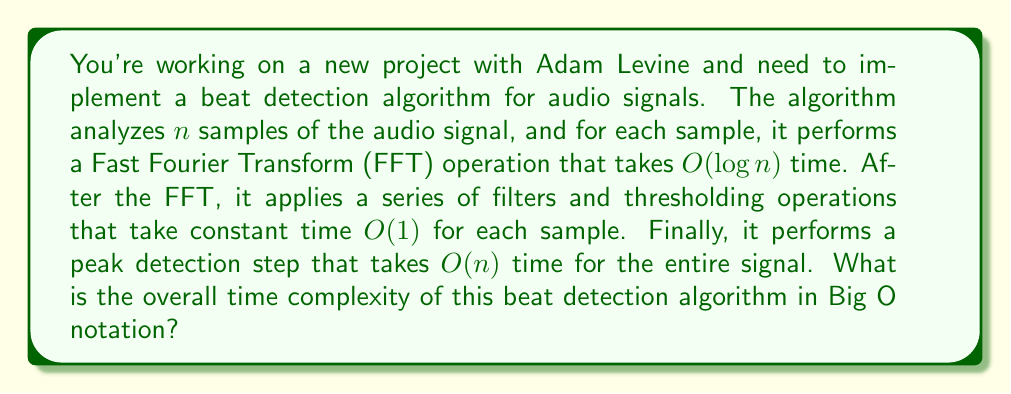Teach me how to tackle this problem. To determine the overall time complexity, let's break down the algorithm into its components:

1. FFT operation:
   - Performed for each of the $n$ samples
   - Each FFT takes $O(\log n)$ time
   - Total time for FFT: $O(n \log n)$

2. Filters and thresholding:
   - Performed for each of the $n$ samples
   - Each operation takes constant time $O(1)$
   - Total time for filters and thresholding: $O(n)$

3. Peak detection:
   - Performed once for the entire signal
   - Takes $O(n)$ time

Now, let's combine these components:

$$T(n) = O(n \log n) + O(n) + O(n)$$

The dominant term in this expression is $O(n \log n)$, as it grows faster than $O(n)$ for large values of $n$. Therefore, we can simplify the overall time complexity to:

$$T(n) = O(n \log n)$$

This means that the runtime of the algorithm grows slightly faster than linear time but not as fast as quadratic time, which is relatively efficient for audio processing tasks.
Answer: $O(n \log n)$ 